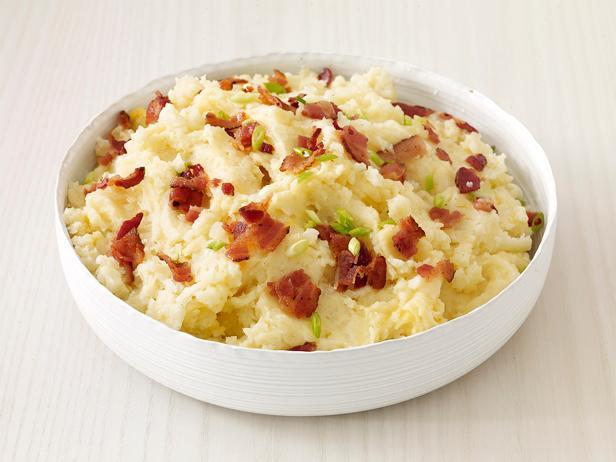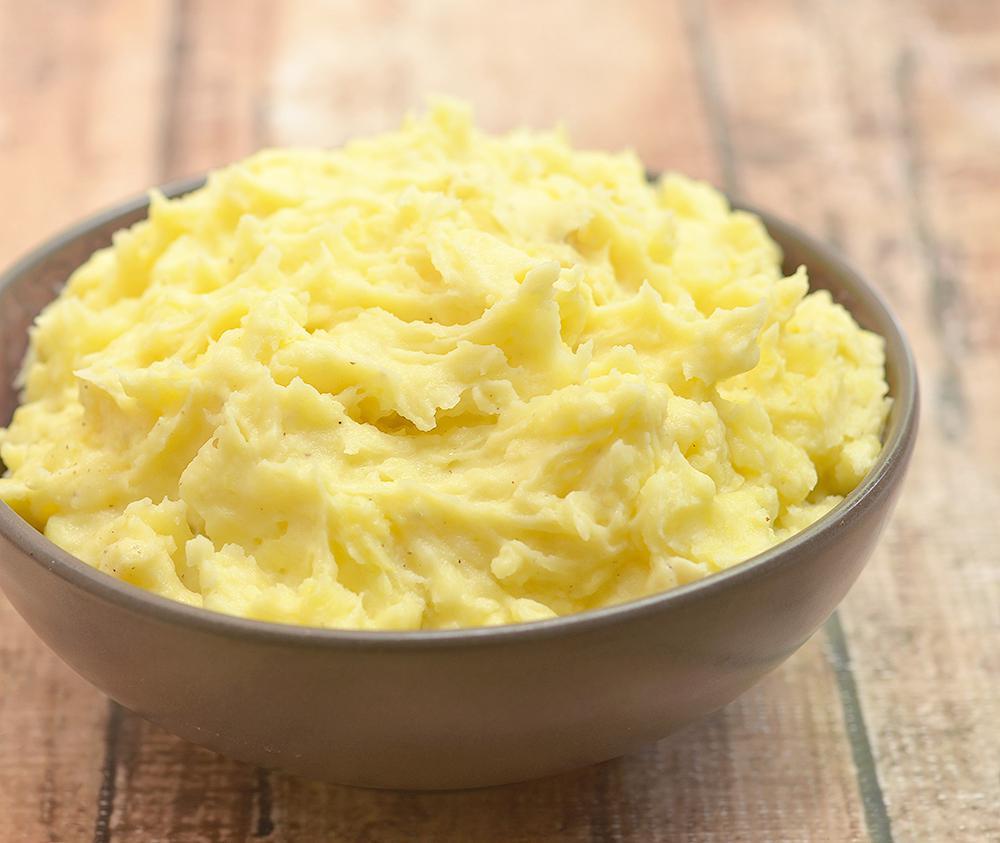The first image is the image on the left, the second image is the image on the right. Examine the images to the left and right. Is the description "The left and right image contains the same number of bowls of mash potatoes." accurate? Answer yes or no. Yes. The first image is the image on the left, the second image is the image on the right. Considering the images on both sides, is "The right image contains mashed potatoes in a green bowl." valid? Answer yes or no. No. 